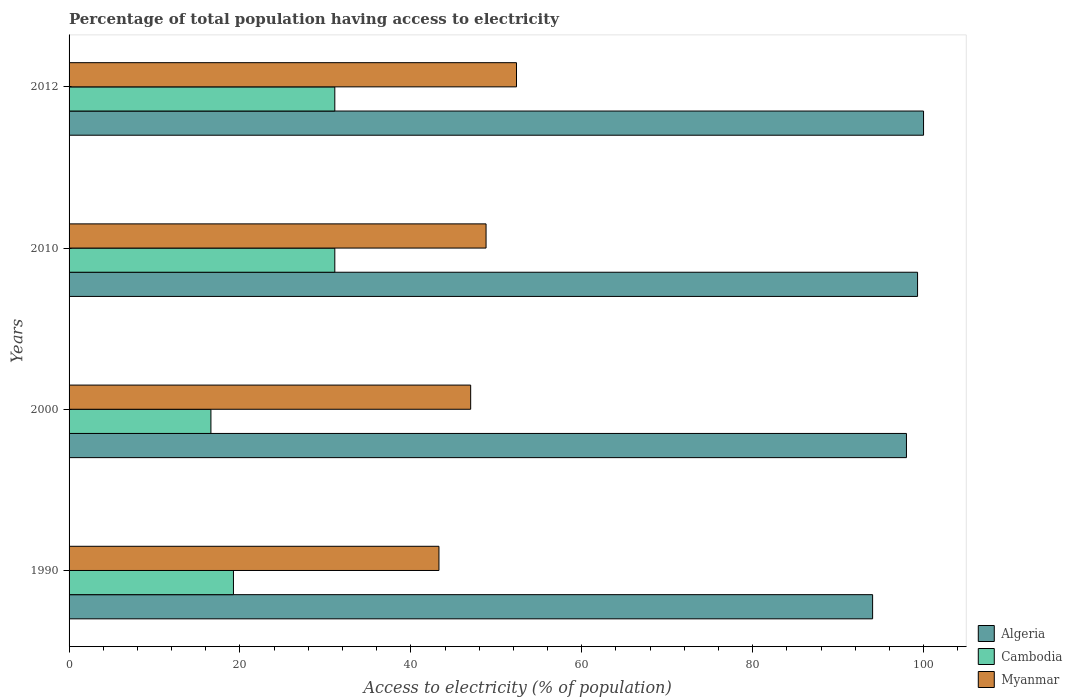How many different coloured bars are there?
Offer a terse response. 3. How many groups of bars are there?
Your answer should be very brief. 4. Are the number of bars per tick equal to the number of legend labels?
Your answer should be very brief. Yes. How many bars are there on the 1st tick from the top?
Provide a short and direct response. 3. What is the label of the 2nd group of bars from the top?
Keep it short and to the point. 2010. What is the percentage of population that have access to electricity in Algeria in 1990?
Ensure brevity in your answer.  94.04. Across all years, what is the maximum percentage of population that have access to electricity in Myanmar?
Your response must be concise. 52.36. Across all years, what is the minimum percentage of population that have access to electricity in Myanmar?
Your response must be concise. 43.29. In which year was the percentage of population that have access to electricity in Cambodia maximum?
Your answer should be very brief. 2010. In which year was the percentage of population that have access to electricity in Cambodia minimum?
Make the answer very short. 2000. What is the total percentage of population that have access to electricity in Algeria in the graph?
Give a very brief answer. 391.34. What is the difference between the percentage of population that have access to electricity in Cambodia in 1990 and the percentage of population that have access to electricity in Algeria in 2010?
Offer a very short reply. -80.06. What is the average percentage of population that have access to electricity in Myanmar per year?
Your response must be concise. 47.86. In the year 2010, what is the difference between the percentage of population that have access to electricity in Cambodia and percentage of population that have access to electricity in Algeria?
Offer a terse response. -68.2. What is the ratio of the percentage of population that have access to electricity in Cambodia in 2000 to that in 2010?
Offer a very short reply. 0.53. Is the difference between the percentage of population that have access to electricity in Cambodia in 1990 and 2012 greater than the difference between the percentage of population that have access to electricity in Algeria in 1990 and 2012?
Ensure brevity in your answer.  No. What is the difference between the highest and the lowest percentage of population that have access to electricity in Myanmar?
Offer a terse response. 9.07. What does the 2nd bar from the top in 2000 represents?
Make the answer very short. Cambodia. What does the 3rd bar from the bottom in 2012 represents?
Your answer should be very brief. Myanmar. How many bars are there?
Your answer should be compact. 12. Are the values on the major ticks of X-axis written in scientific E-notation?
Offer a very short reply. No. Does the graph contain grids?
Keep it short and to the point. No. How many legend labels are there?
Make the answer very short. 3. What is the title of the graph?
Make the answer very short. Percentage of total population having access to electricity. What is the label or title of the X-axis?
Offer a very short reply. Access to electricity (% of population). What is the label or title of the Y-axis?
Provide a succinct answer. Years. What is the Access to electricity (% of population) of Algeria in 1990?
Your answer should be very brief. 94.04. What is the Access to electricity (% of population) of Cambodia in 1990?
Provide a short and direct response. 19.24. What is the Access to electricity (% of population) of Myanmar in 1990?
Provide a succinct answer. 43.29. What is the Access to electricity (% of population) in Cambodia in 2000?
Make the answer very short. 16.6. What is the Access to electricity (% of population) in Algeria in 2010?
Keep it short and to the point. 99.3. What is the Access to electricity (% of population) in Cambodia in 2010?
Your response must be concise. 31.1. What is the Access to electricity (% of population) of Myanmar in 2010?
Give a very brief answer. 48.8. What is the Access to electricity (% of population) of Algeria in 2012?
Your answer should be compact. 100. What is the Access to electricity (% of population) in Cambodia in 2012?
Provide a short and direct response. 31.1. What is the Access to electricity (% of population) of Myanmar in 2012?
Provide a short and direct response. 52.36. Across all years, what is the maximum Access to electricity (% of population) in Cambodia?
Your response must be concise. 31.1. Across all years, what is the maximum Access to electricity (% of population) in Myanmar?
Provide a short and direct response. 52.36. Across all years, what is the minimum Access to electricity (% of population) of Algeria?
Provide a succinct answer. 94.04. Across all years, what is the minimum Access to electricity (% of population) in Cambodia?
Make the answer very short. 16.6. Across all years, what is the minimum Access to electricity (% of population) in Myanmar?
Make the answer very short. 43.29. What is the total Access to electricity (% of population) in Algeria in the graph?
Provide a succinct answer. 391.34. What is the total Access to electricity (% of population) of Cambodia in the graph?
Your answer should be compact. 98.04. What is the total Access to electricity (% of population) of Myanmar in the graph?
Provide a succinct answer. 191.45. What is the difference between the Access to electricity (% of population) of Algeria in 1990 and that in 2000?
Make the answer very short. -3.96. What is the difference between the Access to electricity (% of population) in Cambodia in 1990 and that in 2000?
Your response must be concise. 2.64. What is the difference between the Access to electricity (% of population) in Myanmar in 1990 and that in 2000?
Make the answer very short. -3.71. What is the difference between the Access to electricity (% of population) in Algeria in 1990 and that in 2010?
Offer a very short reply. -5.26. What is the difference between the Access to electricity (% of population) in Cambodia in 1990 and that in 2010?
Offer a very short reply. -11.86. What is the difference between the Access to electricity (% of population) in Myanmar in 1990 and that in 2010?
Keep it short and to the point. -5.51. What is the difference between the Access to electricity (% of population) of Algeria in 1990 and that in 2012?
Your answer should be very brief. -5.96. What is the difference between the Access to electricity (% of population) in Cambodia in 1990 and that in 2012?
Give a very brief answer. -11.86. What is the difference between the Access to electricity (% of population) in Myanmar in 1990 and that in 2012?
Offer a terse response. -9.07. What is the difference between the Access to electricity (% of population) of Algeria in 2000 and that in 2010?
Keep it short and to the point. -1.3. What is the difference between the Access to electricity (% of population) of Myanmar in 2000 and that in 2010?
Offer a very short reply. -1.8. What is the difference between the Access to electricity (% of population) of Myanmar in 2000 and that in 2012?
Give a very brief answer. -5.36. What is the difference between the Access to electricity (% of population) in Cambodia in 2010 and that in 2012?
Provide a short and direct response. 0. What is the difference between the Access to electricity (% of population) in Myanmar in 2010 and that in 2012?
Provide a short and direct response. -3.56. What is the difference between the Access to electricity (% of population) of Algeria in 1990 and the Access to electricity (% of population) of Cambodia in 2000?
Ensure brevity in your answer.  77.44. What is the difference between the Access to electricity (% of population) in Algeria in 1990 and the Access to electricity (% of population) in Myanmar in 2000?
Offer a terse response. 47.04. What is the difference between the Access to electricity (% of population) of Cambodia in 1990 and the Access to electricity (% of population) of Myanmar in 2000?
Give a very brief answer. -27.76. What is the difference between the Access to electricity (% of population) in Algeria in 1990 and the Access to electricity (% of population) in Cambodia in 2010?
Your answer should be very brief. 62.94. What is the difference between the Access to electricity (% of population) of Algeria in 1990 and the Access to electricity (% of population) of Myanmar in 2010?
Provide a succinct answer. 45.24. What is the difference between the Access to electricity (% of population) in Cambodia in 1990 and the Access to electricity (% of population) in Myanmar in 2010?
Your answer should be compact. -29.56. What is the difference between the Access to electricity (% of population) in Algeria in 1990 and the Access to electricity (% of population) in Cambodia in 2012?
Offer a very short reply. 62.94. What is the difference between the Access to electricity (% of population) in Algeria in 1990 and the Access to electricity (% of population) in Myanmar in 2012?
Offer a very short reply. 41.68. What is the difference between the Access to electricity (% of population) of Cambodia in 1990 and the Access to electricity (% of population) of Myanmar in 2012?
Offer a terse response. -33.12. What is the difference between the Access to electricity (% of population) of Algeria in 2000 and the Access to electricity (% of population) of Cambodia in 2010?
Your response must be concise. 66.9. What is the difference between the Access to electricity (% of population) of Algeria in 2000 and the Access to electricity (% of population) of Myanmar in 2010?
Your response must be concise. 49.2. What is the difference between the Access to electricity (% of population) of Cambodia in 2000 and the Access to electricity (% of population) of Myanmar in 2010?
Offer a very short reply. -32.2. What is the difference between the Access to electricity (% of population) of Algeria in 2000 and the Access to electricity (% of population) of Cambodia in 2012?
Keep it short and to the point. 66.9. What is the difference between the Access to electricity (% of population) of Algeria in 2000 and the Access to electricity (% of population) of Myanmar in 2012?
Your response must be concise. 45.64. What is the difference between the Access to electricity (% of population) of Cambodia in 2000 and the Access to electricity (% of population) of Myanmar in 2012?
Ensure brevity in your answer.  -35.76. What is the difference between the Access to electricity (% of population) of Algeria in 2010 and the Access to electricity (% of population) of Cambodia in 2012?
Your answer should be compact. 68.2. What is the difference between the Access to electricity (% of population) of Algeria in 2010 and the Access to electricity (% of population) of Myanmar in 2012?
Ensure brevity in your answer.  46.94. What is the difference between the Access to electricity (% of population) in Cambodia in 2010 and the Access to electricity (% of population) in Myanmar in 2012?
Offer a very short reply. -21.26. What is the average Access to electricity (% of population) of Algeria per year?
Provide a short and direct response. 97.83. What is the average Access to electricity (% of population) of Cambodia per year?
Keep it short and to the point. 24.51. What is the average Access to electricity (% of population) in Myanmar per year?
Ensure brevity in your answer.  47.86. In the year 1990, what is the difference between the Access to electricity (% of population) of Algeria and Access to electricity (% of population) of Cambodia?
Offer a very short reply. 74.8. In the year 1990, what is the difference between the Access to electricity (% of population) in Algeria and Access to electricity (% of population) in Myanmar?
Your response must be concise. 50.75. In the year 1990, what is the difference between the Access to electricity (% of population) of Cambodia and Access to electricity (% of population) of Myanmar?
Make the answer very short. -24.05. In the year 2000, what is the difference between the Access to electricity (% of population) of Algeria and Access to electricity (% of population) of Cambodia?
Provide a short and direct response. 81.4. In the year 2000, what is the difference between the Access to electricity (% of population) of Cambodia and Access to electricity (% of population) of Myanmar?
Offer a terse response. -30.4. In the year 2010, what is the difference between the Access to electricity (% of population) of Algeria and Access to electricity (% of population) of Cambodia?
Give a very brief answer. 68.2. In the year 2010, what is the difference between the Access to electricity (% of population) of Algeria and Access to electricity (% of population) of Myanmar?
Your response must be concise. 50.5. In the year 2010, what is the difference between the Access to electricity (% of population) of Cambodia and Access to electricity (% of population) of Myanmar?
Your response must be concise. -17.7. In the year 2012, what is the difference between the Access to electricity (% of population) in Algeria and Access to electricity (% of population) in Cambodia?
Give a very brief answer. 68.9. In the year 2012, what is the difference between the Access to electricity (% of population) in Algeria and Access to electricity (% of population) in Myanmar?
Provide a succinct answer. 47.64. In the year 2012, what is the difference between the Access to electricity (% of population) of Cambodia and Access to electricity (% of population) of Myanmar?
Your answer should be compact. -21.26. What is the ratio of the Access to electricity (% of population) in Algeria in 1990 to that in 2000?
Provide a succinct answer. 0.96. What is the ratio of the Access to electricity (% of population) of Cambodia in 1990 to that in 2000?
Your answer should be very brief. 1.16. What is the ratio of the Access to electricity (% of population) of Myanmar in 1990 to that in 2000?
Your answer should be very brief. 0.92. What is the ratio of the Access to electricity (% of population) of Algeria in 1990 to that in 2010?
Your answer should be compact. 0.95. What is the ratio of the Access to electricity (% of population) of Cambodia in 1990 to that in 2010?
Offer a very short reply. 0.62. What is the ratio of the Access to electricity (% of population) in Myanmar in 1990 to that in 2010?
Offer a very short reply. 0.89. What is the ratio of the Access to electricity (% of population) of Algeria in 1990 to that in 2012?
Your answer should be compact. 0.94. What is the ratio of the Access to electricity (% of population) of Cambodia in 1990 to that in 2012?
Keep it short and to the point. 0.62. What is the ratio of the Access to electricity (% of population) of Myanmar in 1990 to that in 2012?
Provide a succinct answer. 0.83. What is the ratio of the Access to electricity (% of population) of Algeria in 2000 to that in 2010?
Offer a very short reply. 0.99. What is the ratio of the Access to electricity (% of population) of Cambodia in 2000 to that in 2010?
Provide a short and direct response. 0.53. What is the ratio of the Access to electricity (% of population) in Myanmar in 2000 to that in 2010?
Keep it short and to the point. 0.96. What is the ratio of the Access to electricity (% of population) in Cambodia in 2000 to that in 2012?
Your response must be concise. 0.53. What is the ratio of the Access to electricity (% of population) of Myanmar in 2000 to that in 2012?
Make the answer very short. 0.9. What is the ratio of the Access to electricity (% of population) in Cambodia in 2010 to that in 2012?
Give a very brief answer. 1. What is the ratio of the Access to electricity (% of population) in Myanmar in 2010 to that in 2012?
Your answer should be compact. 0.93. What is the difference between the highest and the second highest Access to electricity (% of population) of Algeria?
Your answer should be very brief. 0.7. What is the difference between the highest and the second highest Access to electricity (% of population) of Cambodia?
Provide a short and direct response. 0. What is the difference between the highest and the second highest Access to electricity (% of population) of Myanmar?
Provide a short and direct response. 3.56. What is the difference between the highest and the lowest Access to electricity (% of population) of Algeria?
Your response must be concise. 5.96. What is the difference between the highest and the lowest Access to electricity (% of population) in Cambodia?
Your answer should be very brief. 14.5. What is the difference between the highest and the lowest Access to electricity (% of population) of Myanmar?
Your answer should be very brief. 9.07. 